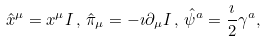<formula> <loc_0><loc_0><loc_500><loc_500>\hat { x } ^ { \mu } = x ^ { \mu } { I } \, , \, \hat { \pi } _ { \mu } = - \imath \partial _ { \mu } { I } \, , \, \hat { \psi } ^ { a } = \frac { \imath } { 2 } \gamma ^ { a } ,</formula> 